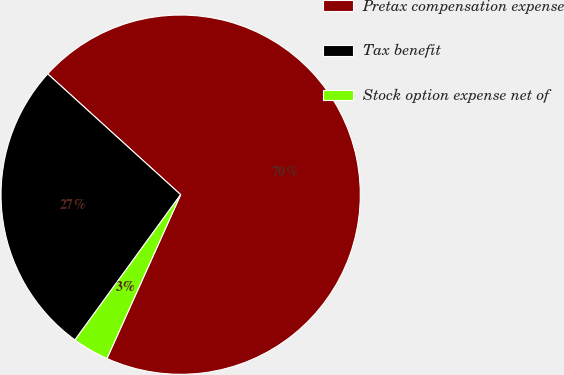Convert chart to OTSL. <chart><loc_0><loc_0><loc_500><loc_500><pie_chart><fcel>Pretax compensation expense<fcel>Tax benefit<fcel>Stock option expense net of<nl><fcel>70.0%<fcel>26.73%<fcel>3.28%<nl></chart> 